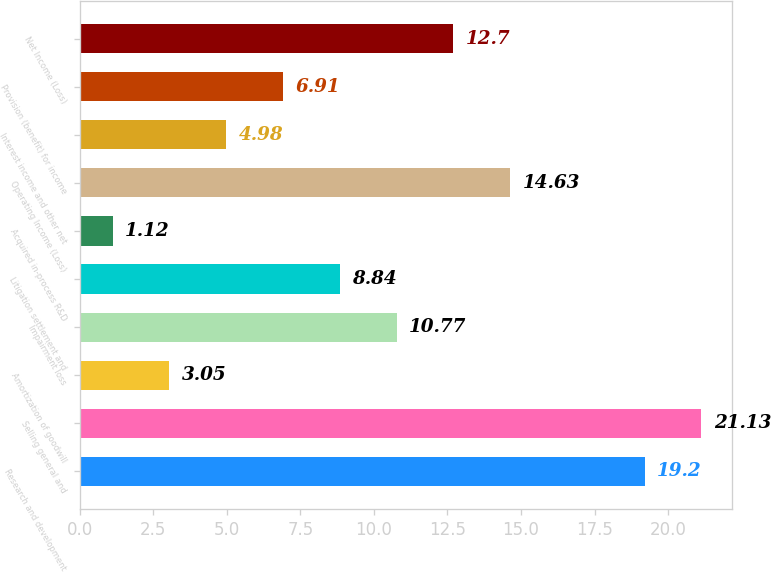<chart> <loc_0><loc_0><loc_500><loc_500><bar_chart><fcel>Research and development<fcel>Selling general and<fcel>Amortization of goodwill<fcel>Impairment loss<fcel>Litigation settlement and<fcel>Acquired in-process R&D<fcel>Operating Income (Loss)<fcel>Interest income and other net<fcel>Provision (benefit) for income<fcel>Net Income (Loss)<nl><fcel>19.2<fcel>21.13<fcel>3.05<fcel>10.77<fcel>8.84<fcel>1.12<fcel>14.63<fcel>4.98<fcel>6.91<fcel>12.7<nl></chart> 